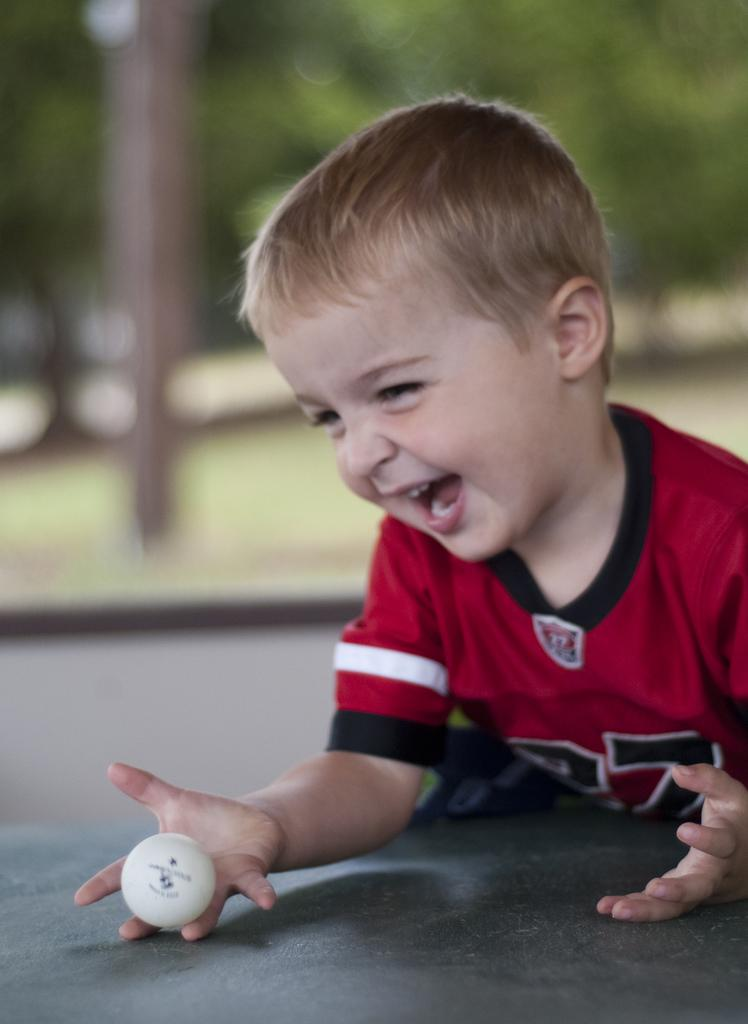Who is the main subject in the image? There is a boy in the image. What is the boy holding in the image? The boy is holding a ball. What is the surface beneath the boy in the image? There is a floor at the bottom of the image. What can be seen in the distance behind the boy? There are trees in the background of the image. How would you describe the appearance of the background in the image? The background of the image is blurred. What type of match is the boy playing in the image? There is no match or competition present in the image; it simply shows a boy holding a ball. What is the engine used for in the image? There is no engine present in the image. 